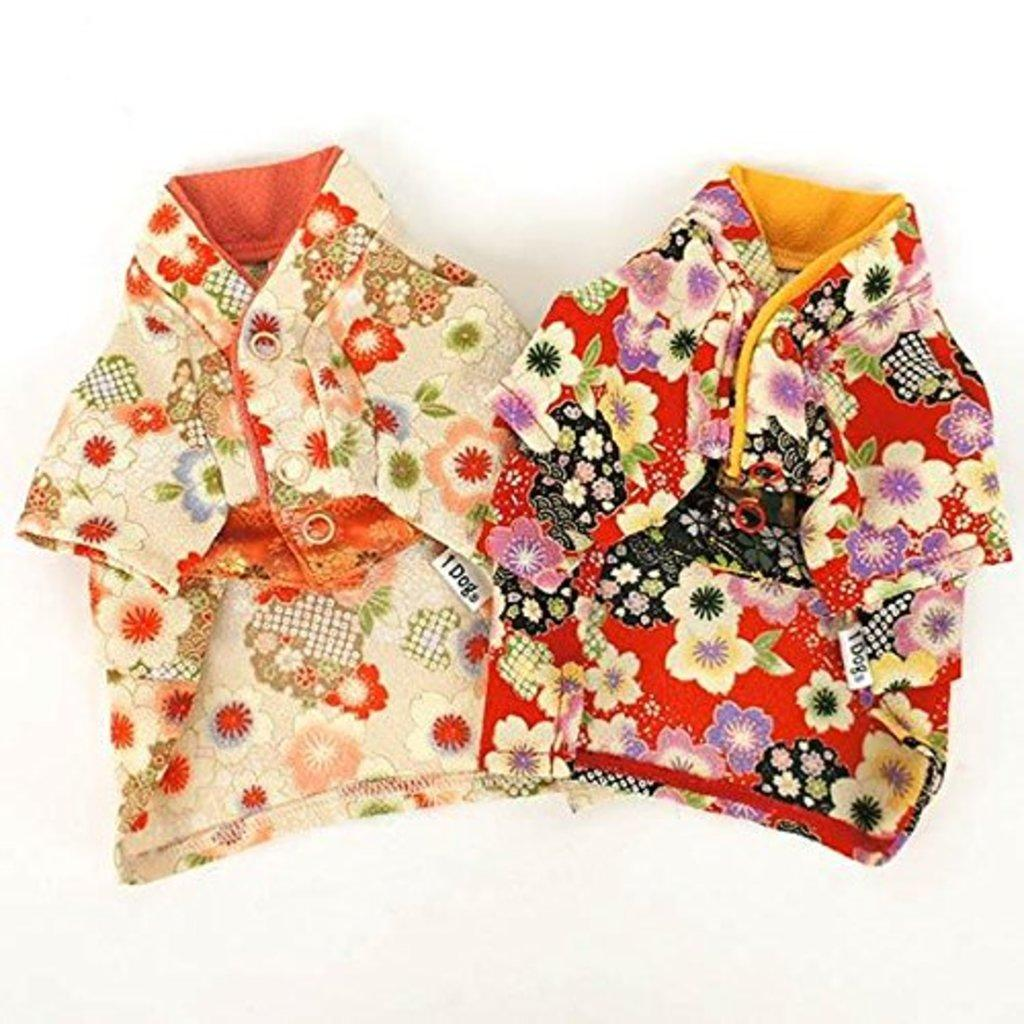What type of clothing is on the left side of the image? There is a dress with orange flowers on the left side of the image. What color is the floor in the image? The dress is on a white floor. What type of clothing is on the right side of the image? There is a red dress on the right side of the image. What colors and patterns are featured on the red dress? The red dress has white and violet flowers in it. Can you see a lake in the background of the image? There is no lake present in the image; it only features two dresses on a white floor. 